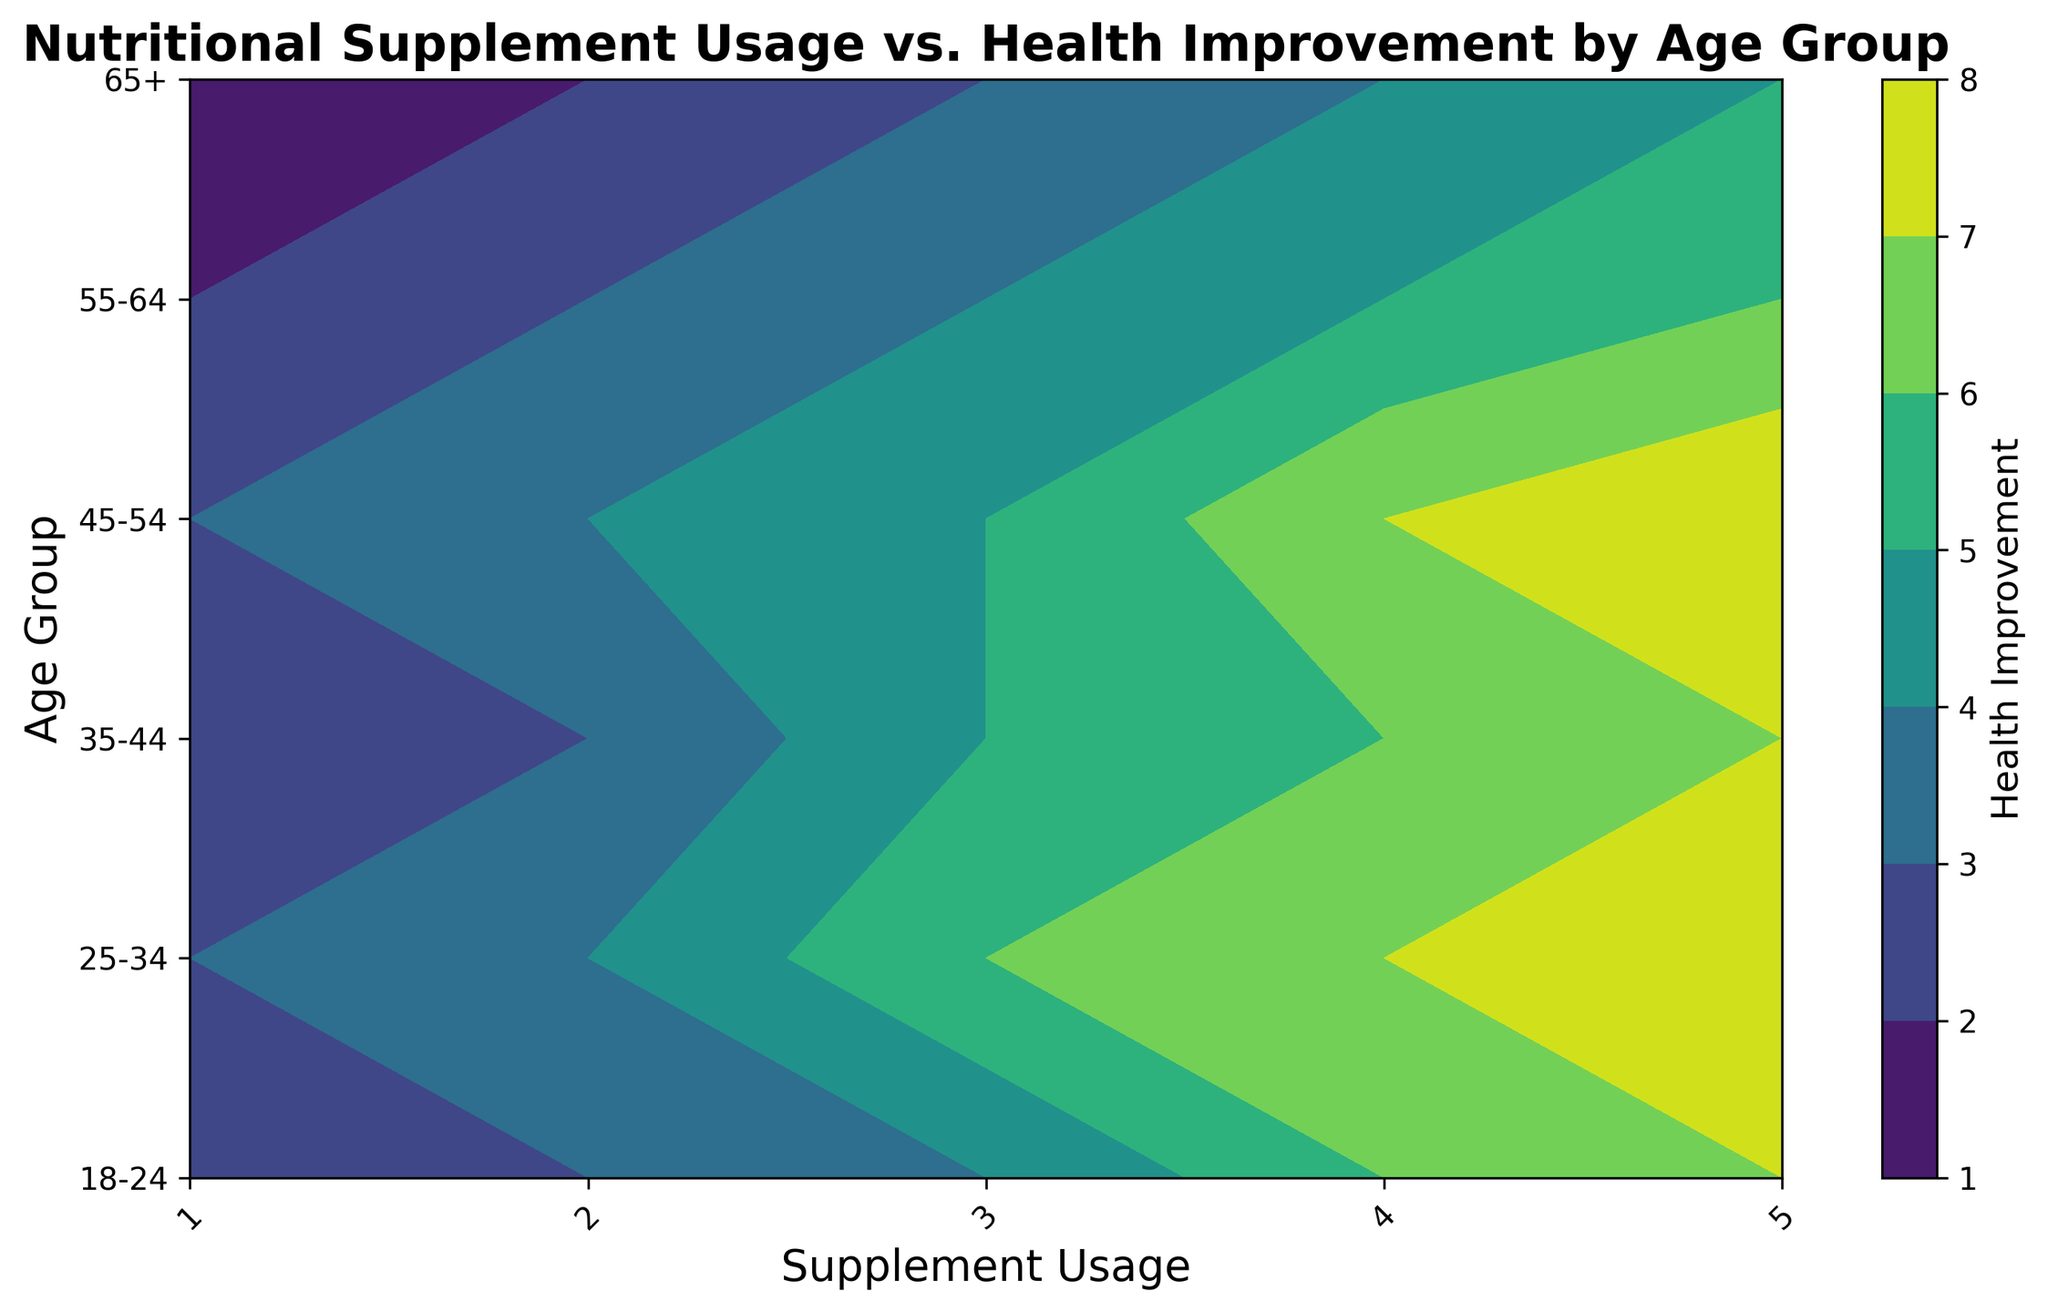Which age group shows the most significant health improvement with increased supplement usage? By observing the contour plot, we see that the 25-34 age group shows the darkest shades of color, indicating higher health improvement with increased supplement usage. Therefore, the 25-34 age group shows the most significant health improvement.
Answer: 25-34 Which age group has the least health improvement with maximum supplement usage? By examining the darkest shade representing health improvements for the maximum supplement usage level (5), we notice that the 65+ age group has the least health improvement.
Answer: 65+ Compare the health improvement for the 35-44 age group between supplement usage levels 3 and 4. In the contour plot, for the 35-44 age group (y-axis), the health improvement is marked by specific contour levels. At supplement usage level 3, the health improvement is 5, while at level 4, it is 6.
Answer: 6 is greater than 5 What is the total health improvement difference between supplement usage levels 1 and 5 for the 45-54 age group? Observing the contour plot, at usage level 1, the health improvement is 3, and at usage level 5, it is 8 for the 45-54 age group. The difference is 8 - 3 = 5.
Answer: 5 Which age group has a consistent increase in health improvement with each increase in supplement usage? By analyzing the contour plot, it is evident that the 55-64 age group has a steady increase in health improvement with each increment in supplement usage from 1 to 5.
Answer: 55-64 Identify the range of supplement usage where the 18-24 age group sees the most rapid health improvement increase. From the contour plot, the 18-24 age group observes the steepest increase in health improvement between usage levels 3 and 4, moving from 4 to 6.
Answer: 3 to 4 What is the average health improvement for the 65+ age group across all supplement usage levels? For the 65+ age group, the health improvements are: 1, 2, 3, 4, and 5 across usage levels 1 to 5, respectively. Sum = 1+2+3+4+5 = 15. Average = 15/5 = 3.
Answer: 3 Compare the health improvement of supplement usage level 2 across all age groups. Which age group benefits the most? By checking the contour plot, at supplement usage level 2, the health improvements are as follows: 18-24 (3), 25-34 (4), 35-44 (3), 45-54 (4), 55-64 (3), 65+ (2). The 25-34 and 45-54 age groups both show the highest improvement of 4.
Answer: 25-34 and 45-54 